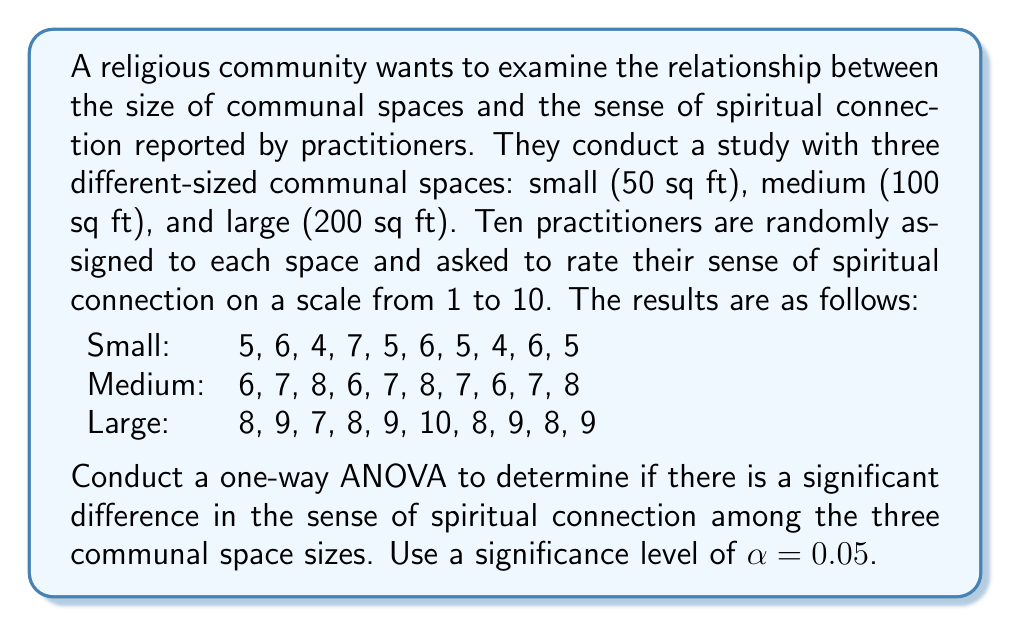Teach me how to tackle this problem. To conduct a one-way ANOVA, we'll follow these steps:

1. Calculate the sum of squares between groups (SSB), within groups (SSW), and total (SST).
2. Calculate the degrees of freedom for between groups (dfB), within groups (dfW), and total (dfT).
3. Calculate the mean squares between groups (MSB) and within groups (MSW).
4. Calculate the F-statistic.
5. Determine the critical F-value and compare it with the calculated F-statistic.

Step 1: Calculate sum of squares

First, we need to calculate the grand mean:
$$\bar{X} = \frac{5+6+4+...+8+9}{30} = 6.93$$

Now, we can calculate SSB, SSW, and SST:

SSB = $\sum_{i=1}^{k} n_i(\bar{X_i} - \bar{X})^2$
    = $10(5.3 - 6.93)^2 + 10(7.0 - 6.93)^2 + 10(8.5 - 6.93)^2$
    = $26.45 + 0.05 + 24.65 = 51.15$

SSW = $\sum_{i=1}^{k} \sum_{j=1}^{n_i} (X_{ij} - \bar{X_i})^2$
    = $[(5-5.3)^2 + (6-5.3)^2 + ... + (5-5.3)^2]$
    + $[(6-7.0)^2 + (7-7.0)^2 + ... + (8-7.0)^2]$
    + $[(8-8.5)^2 + (9-8.5)^2 + ... + (9-8.5)^2]$
    = $8.1 + 6.0 + 7.0 = 21.1$

SST = SSB + SSW = $51.15 + 21.1 = 72.25$

Step 2: Calculate degrees of freedom

dfB = k - 1 = 3 - 1 = 2
dfW = N - k = 30 - 3 = 27
dfT = N - 1 = 30 - 1 = 29

Step 3: Calculate mean squares

MSB = SSB / dfB = 51.15 / 2 = 25.575
MSW = SSW / dfW = 21.1 / 27 = 0.781

Step 4: Calculate F-statistic

F = MSB / MSW = 25.575 / 0.781 = 32.75

Step 5: Determine critical F-value and compare

For $\alpha = 0.05$, dfB = 2, and dfW = 27, the critical F-value is approximately 3.35 (from an F-distribution table).

Since our calculated F-statistic (32.75) is greater than the critical F-value (3.35), we reject the null hypothesis.
Answer: The one-way ANOVA results in an F-statistic of 32.75, which is greater than the critical F-value of 3.35 at $\alpha = 0.05$. Therefore, we reject the null hypothesis and conclude that there is a significant difference in the sense of spiritual connection among the three communal space sizes. 